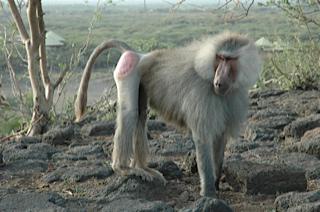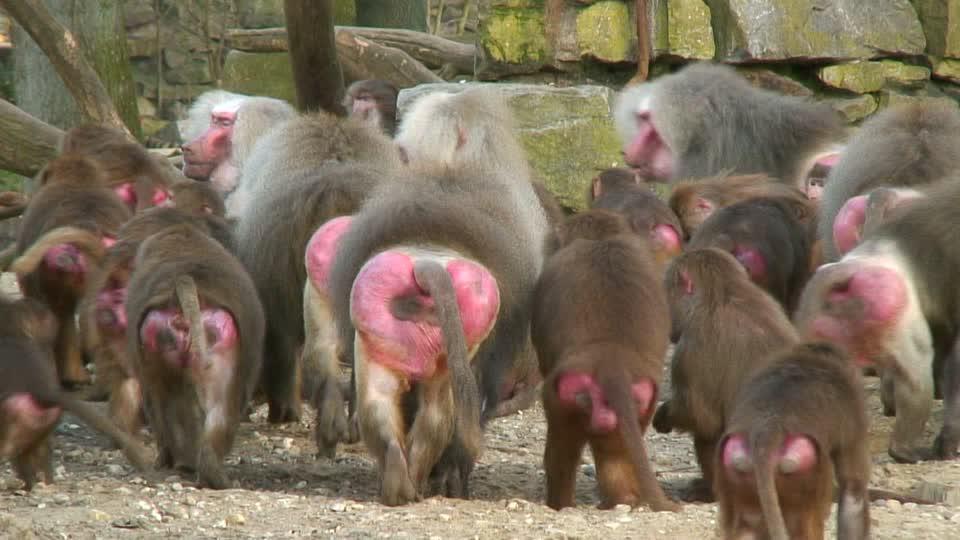The first image is the image on the left, the second image is the image on the right. Examine the images to the left and right. Is the description "An image shows multiple rear-facing baboons with bulbous pink rears." accurate? Answer yes or no. Yes. The first image is the image on the left, the second image is the image on the right. For the images displayed, is the sentence "The pink rear ends of several primates are visible." factually correct? Answer yes or no. Yes. 